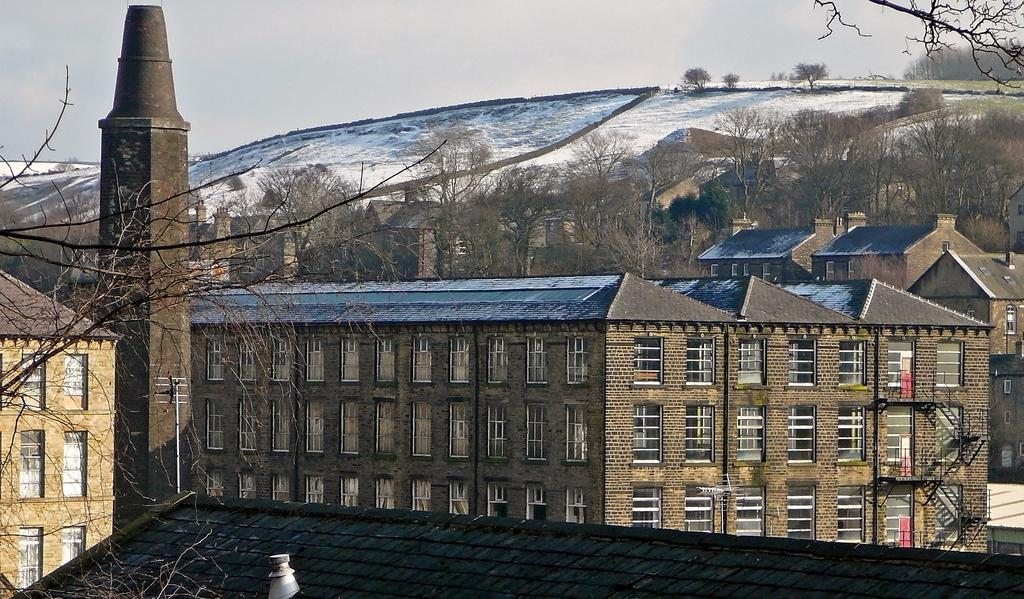What type of structures are present in the image? There are buildings with windows in the image. What other natural elements can be seen in the image? There are trees in the image. What part of the environment is visible beneath the structures? The ground is visible in the image. What is visible above the structures and trees? The sky is visible in the image. What type of calculator is being used by the fireman in the image? There is no fireman or calculator present in the image. What is the zephyr's role in the image? There is no zephyr present in the image. 